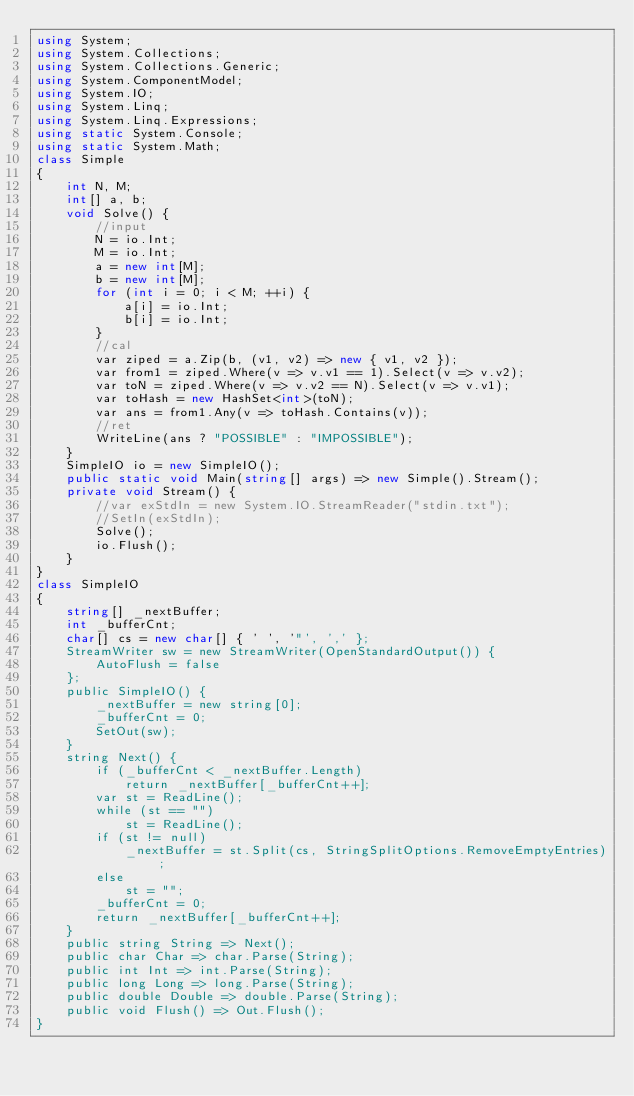<code> <loc_0><loc_0><loc_500><loc_500><_C#_>using System;
using System.Collections;
using System.Collections.Generic;
using System.ComponentModel;
using System.IO;
using System.Linq;
using System.Linq.Expressions;
using static System.Console;
using static System.Math;
class Simple
{
    int N, M;
    int[] a, b;
    void Solve() {
        //input
        N = io.Int;
        M = io.Int;
        a = new int[M];
        b = new int[M];
        for (int i = 0; i < M; ++i) {
            a[i] = io.Int;
            b[i] = io.Int;
        }
        //cal        
        var ziped = a.Zip(b, (v1, v2) => new { v1, v2 });
        var from1 = ziped.Where(v => v.v1 == 1).Select(v => v.v2);
        var toN = ziped.Where(v => v.v2 == N).Select(v => v.v1);
        var toHash = new HashSet<int>(toN);
        var ans = from1.Any(v => toHash.Contains(v));
        //ret
        WriteLine(ans ? "POSSIBLE" : "IMPOSSIBLE");
    }
    SimpleIO io = new SimpleIO();
    public static void Main(string[] args) => new Simple().Stream();
    private void Stream() {
        //var exStdIn = new System.IO.StreamReader("stdin.txt");
        //SetIn(exStdIn);
        Solve();
        io.Flush();
    }
}
class SimpleIO
{
    string[] _nextBuffer;
    int _bufferCnt;
    char[] cs = new char[] { ' ', '"', ',' };
    StreamWriter sw = new StreamWriter(OpenStandardOutput()) {
        AutoFlush = false
    };
    public SimpleIO() {
        _nextBuffer = new string[0];
        _bufferCnt = 0;
        SetOut(sw);
    }
    string Next() {
        if (_bufferCnt < _nextBuffer.Length)
            return _nextBuffer[_bufferCnt++];
        var st = ReadLine();
        while (st == "")
            st = ReadLine();
        if (st != null)
            _nextBuffer = st.Split(cs, StringSplitOptions.RemoveEmptyEntries);
        else
            st = "";
        _bufferCnt = 0;
        return _nextBuffer[_bufferCnt++];
    }
    public string String => Next();
    public char Char => char.Parse(String);
    public int Int => int.Parse(String);
    public long Long => long.Parse(String);
    public double Double => double.Parse(String);
    public void Flush() => Out.Flush();
}
</code> 